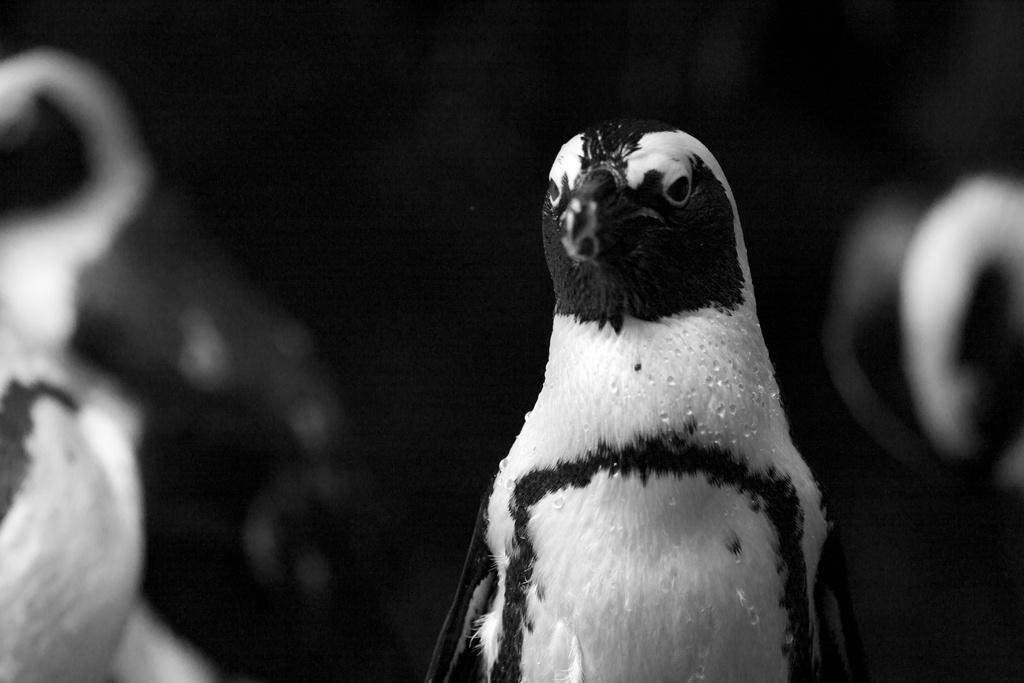What type of animal can be seen in the image? There is a bird in the image. What is the color scheme of the image? The image is in black and white. What type of pollution is visible in the image? There is no pollution visible in the image; it features a bird in black and white. What type of drink is the bird holding in the image? There is no drink present in the image, as it features a bird and is in black and white. 